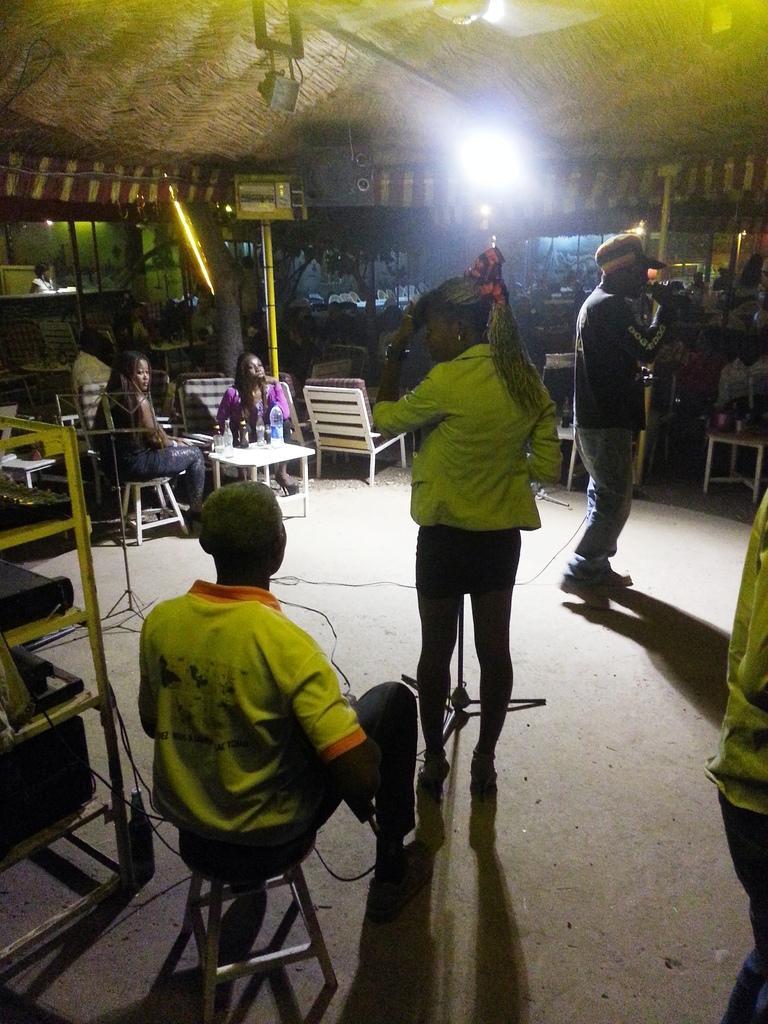Please provide a concise description of this image. There is one person sitting on a table and wearing a yellow color t shirt at the bottom of this image. There is one women standing in the middle is also wearing yellow color jacket. There is one person standing on the right side to this person is holding a Mic. There are some persons sitting on the chairs in the background. There is a tent at the top of this image. There is a light on the left side of this image. 